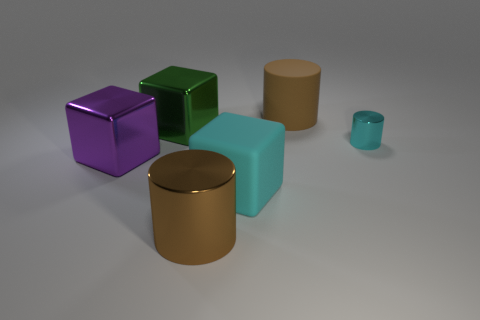Is there any other thing that is the same shape as the big green object?
Give a very brief answer. Yes. There is a thing that is the same color as the large shiny cylinder; what material is it?
Offer a very short reply. Rubber. How many large brown things are to the left of the purple object left of the big matte object that is behind the purple metal cube?
Offer a terse response. 0. There is a large purple cube; what number of shiny cubes are to the right of it?
Your response must be concise. 1. What number of big cyan things are the same material as the big cyan block?
Keep it short and to the point. 0. There is a big cylinder that is made of the same material as the purple thing; what is its color?
Make the answer very short. Brown. What material is the brown cylinder that is in front of the large cylinder that is right of the big matte object in front of the large purple metal object?
Your answer should be very brief. Metal. There is a cyan block on the left side of the cyan cylinder; is its size the same as the big green metal block?
Provide a succinct answer. Yes. How many small things are green metallic balls or shiny objects?
Offer a terse response. 1. Are there any blocks that have the same color as the small shiny object?
Make the answer very short. Yes. 